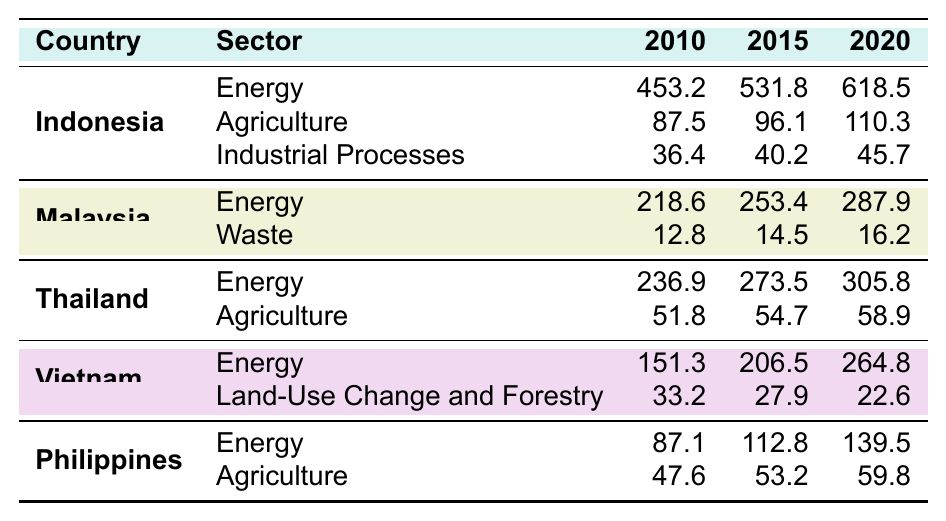What was Indonesia's greenhouse gas emission from the Energy sector in 2020? According to the table, Indonesia's greenhouse gas emission from the Energy sector in 2020 is listed as 618.5.
Answer: 618.5 What is the total greenhouse gas emission from Agriculture in the Philippines for the years 2010, 2015, and 2020? The emissions for Agriculture in the Philippines are 47.6 in 2010, 53.2 in 2015, and 59.8 in 2020. Adding these values gives us 47.6 + 53.2 + 59.8 = 160.6.
Answer: 160.6 Which sector contributed more to greenhouse gas emissions in Thailand in 2020, Energy or Agriculture? In 2020, Thailand's emissions from Energy is 305.8, while from Agriculture it is 58.9. Comparing these values shows Energy is greater than Agriculture.
Answer: Energy What is the percentage increase in greenhouse gas emissions from the Energy sector in Indonesia from 2010 to 2020? The emissions in 2010 were 453.2 and in 2020 they rose to 618.5. The increase is 618.5 - 453.2 = 165.3. The percentage increase is (165.3 / 453.2) * 100 = approximately 36.5%.
Answer: 36.5% Which country had the lowest greenhouse gas emissions in the Agriculture sector in 2015? From the table, the emissions from Agriculture in 2015 are: Indonesia 96.1, Malaysia (not listed), Thailand 54.7, Vietnam (not listed), Philippines 53.2. Therefore, Philippines had the lowest emissions in Agriculture in 2015.
Answer: Philippines What is the total greenhouse gas emissions from the Waste sector in Malaysia from 2010 to 2020? The Waste emissions for Malaysia are given as 12.8 in 2010, 14.5 in 2015, and 16.2 in 2020. Adding these values gives 12.8 + 14.5 + 16.2 = 43.5.
Answer: 43.5 Was there a decrease in emissions from Land-Use Change and Forestry in Vietnam from 2010 to 2020? The emissions from this sector in Vietnam were 33.2 in 2010 and decreased to 22.6 in 2020. Therefore, it confirms there was a decrease in emissions.
Answer: Yes What is the average greenhouse gas emission from the Energy sector across ASEAN countries in 2015? The Energy emissions in 2015 are: Indonesia 531.8, Malaysia 253.4, Thailand 273.5, Vietnam 206.5, and Philippines 112.8. The total is 531.8 + 253.4 + 273.5 + 206.5 + 112.8 = 1378. The average is 1378 / 5 = approximately 275.6.
Answer: 275.6 